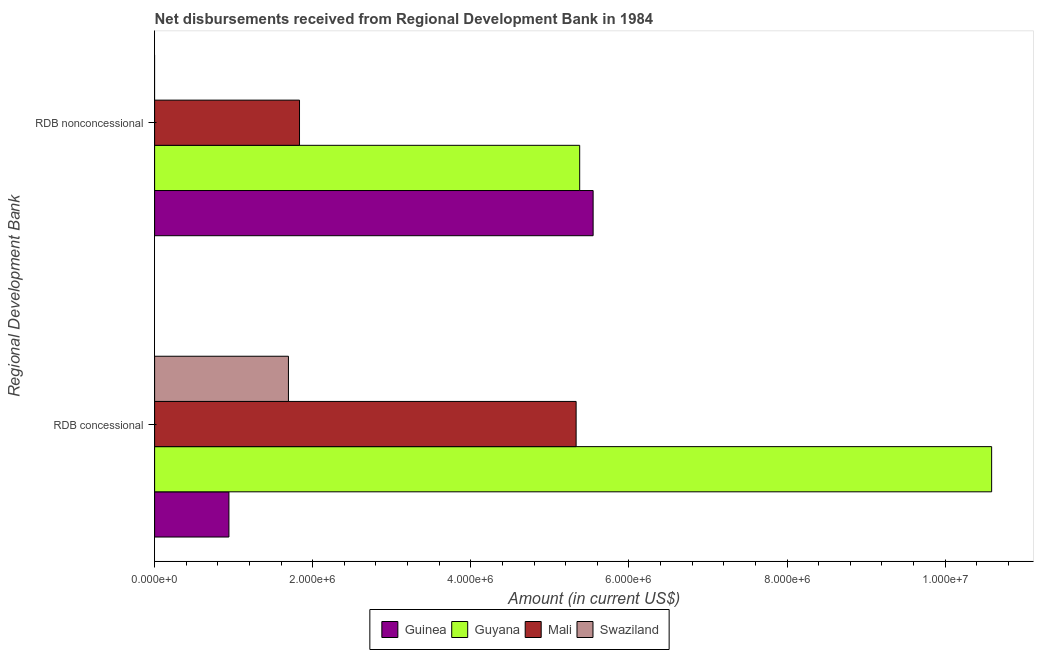How many groups of bars are there?
Make the answer very short. 2. Are the number of bars per tick equal to the number of legend labels?
Your response must be concise. No. How many bars are there on the 1st tick from the bottom?
Give a very brief answer. 4. What is the label of the 2nd group of bars from the top?
Your answer should be very brief. RDB concessional. What is the net non concessional disbursements from rdb in Mali?
Provide a succinct answer. 1.83e+06. Across all countries, what is the maximum net concessional disbursements from rdb?
Give a very brief answer. 1.06e+07. In which country was the net concessional disbursements from rdb maximum?
Provide a succinct answer. Guyana. What is the total net concessional disbursements from rdb in the graph?
Keep it short and to the point. 1.86e+07. What is the difference between the net non concessional disbursements from rdb in Guyana and that in Mali?
Provide a short and direct response. 3.54e+06. What is the difference between the net concessional disbursements from rdb in Mali and the net non concessional disbursements from rdb in Guinea?
Offer a terse response. -2.15e+05. What is the average net non concessional disbursements from rdb per country?
Ensure brevity in your answer.  3.19e+06. What is the difference between the net concessional disbursements from rdb and net non concessional disbursements from rdb in Guyana?
Offer a terse response. 5.21e+06. What is the ratio of the net concessional disbursements from rdb in Guyana to that in Mali?
Provide a succinct answer. 1.99. Is the net concessional disbursements from rdb in Mali less than that in Guyana?
Offer a very short reply. Yes. How many bars are there?
Ensure brevity in your answer.  7. How many countries are there in the graph?
Give a very brief answer. 4. Does the graph contain grids?
Your answer should be compact. No. How many legend labels are there?
Make the answer very short. 4. How are the legend labels stacked?
Your response must be concise. Horizontal. What is the title of the graph?
Provide a short and direct response. Net disbursements received from Regional Development Bank in 1984. Does "Nigeria" appear as one of the legend labels in the graph?
Your answer should be compact. No. What is the label or title of the Y-axis?
Offer a very short reply. Regional Development Bank. What is the Amount (in current US$) of Guinea in RDB concessional?
Give a very brief answer. 9.40e+05. What is the Amount (in current US$) of Guyana in RDB concessional?
Make the answer very short. 1.06e+07. What is the Amount (in current US$) of Mali in RDB concessional?
Offer a terse response. 5.33e+06. What is the Amount (in current US$) of Swaziland in RDB concessional?
Offer a terse response. 1.69e+06. What is the Amount (in current US$) of Guinea in RDB nonconcessional?
Offer a very short reply. 5.55e+06. What is the Amount (in current US$) in Guyana in RDB nonconcessional?
Your response must be concise. 5.38e+06. What is the Amount (in current US$) of Mali in RDB nonconcessional?
Your response must be concise. 1.83e+06. What is the Amount (in current US$) in Swaziland in RDB nonconcessional?
Give a very brief answer. 0. Across all Regional Development Bank, what is the maximum Amount (in current US$) of Guinea?
Provide a short and direct response. 5.55e+06. Across all Regional Development Bank, what is the maximum Amount (in current US$) in Guyana?
Provide a short and direct response. 1.06e+07. Across all Regional Development Bank, what is the maximum Amount (in current US$) in Mali?
Offer a terse response. 5.33e+06. Across all Regional Development Bank, what is the maximum Amount (in current US$) of Swaziland?
Provide a succinct answer. 1.69e+06. Across all Regional Development Bank, what is the minimum Amount (in current US$) in Guinea?
Ensure brevity in your answer.  9.40e+05. Across all Regional Development Bank, what is the minimum Amount (in current US$) of Guyana?
Provide a succinct answer. 5.38e+06. Across all Regional Development Bank, what is the minimum Amount (in current US$) of Mali?
Your answer should be very brief. 1.83e+06. Across all Regional Development Bank, what is the minimum Amount (in current US$) of Swaziland?
Provide a succinct answer. 0. What is the total Amount (in current US$) in Guinea in the graph?
Provide a succinct answer. 6.49e+06. What is the total Amount (in current US$) of Guyana in the graph?
Ensure brevity in your answer.  1.60e+07. What is the total Amount (in current US$) in Mali in the graph?
Offer a terse response. 7.16e+06. What is the total Amount (in current US$) in Swaziland in the graph?
Your answer should be compact. 1.69e+06. What is the difference between the Amount (in current US$) of Guinea in RDB concessional and that in RDB nonconcessional?
Make the answer very short. -4.61e+06. What is the difference between the Amount (in current US$) in Guyana in RDB concessional and that in RDB nonconcessional?
Provide a succinct answer. 5.21e+06. What is the difference between the Amount (in current US$) in Mali in RDB concessional and that in RDB nonconcessional?
Ensure brevity in your answer.  3.50e+06. What is the difference between the Amount (in current US$) in Guinea in RDB concessional and the Amount (in current US$) in Guyana in RDB nonconcessional?
Your response must be concise. -4.44e+06. What is the difference between the Amount (in current US$) of Guinea in RDB concessional and the Amount (in current US$) of Mali in RDB nonconcessional?
Keep it short and to the point. -8.93e+05. What is the difference between the Amount (in current US$) in Guyana in RDB concessional and the Amount (in current US$) in Mali in RDB nonconcessional?
Provide a succinct answer. 8.76e+06. What is the average Amount (in current US$) of Guinea per Regional Development Bank?
Provide a short and direct response. 3.24e+06. What is the average Amount (in current US$) of Guyana per Regional Development Bank?
Your answer should be very brief. 7.98e+06. What is the average Amount (in current US$) of Mali per Regional Development Bank?
Provide a short and direct response. 3.58e+06. What is the average Amount (in current US$) in Swaziland per Regional Development Bank?
Your response must be concise. 8.46e+05. What is the difference between the Amount (in current US$) of Guinea and Amount (in current US$) of Guyana in RDB concessional?
Your answer should be very brief. -9.65e+06. What is the difference between the Amount (in current US$) of Guinea and Amount (in current US$) of Mali in RDB concessional?
Offer a terse response. -4.39e+06. What is the difference between the Amount (in current US$) in Guinea and Amount (in current US$) in Swaziland in RDB concessional?
Your answer should be compact. -7.53e+05. What is the difference between the Amount (in current US$) in Guyana and Amount (in current US$) in Mali in RDB concessional?
Your answer should be compact. 5.26e+06. What is the difference between the Amount (in current US$) of Guyana and Amount (in current US$) of Swaziland in RDB concessional?
Make the answer very short. 8.90e+06. What is the difference between the Amount (in current US$) of Mali and Amount (in current US$) of Swaziland in RDB concessional?
Give a very brief answer. 3.64e+06. What is the difference between the Amount (in current US$) of Guinea and Amount (in current US$) of Guyana in RDB nonconcessional?
Ensure brevity in your answer.  1.70e+05. What is the difference between the Amount (in current US$) in Guinea and Amount (in current US$) in Mali in RDB nonconcessional?
Give a very brief answer. 3.71e+06. What is the difference between the Amount (in current US$) in Guyana and Amount (in current US$) in Mali in RDB nonconcessional?
Your answer should be very brief. 3.54e+06. What is the ratio of the Amount (in current US$) of Guinea in RDB concessional to that in RDB nonconcessional?
Your response must be concise. 0.17. What is the ratio of the Amount (in current US$) of Guyana in RDB concessional to that in RDB nonconcessional?
Provide a succinct answer. 1.97. What is the ratio of the Amount (in current US$) of Mali in RDB concessional to that in RDB nonconcessional?
Provide a succinct answer. 2.91. What is the difference between the highest and the second highest Amount (in current US$) of Guinea?
Your answer should be very brief. 4.61e+06. What is the difference between the highest and the second highest Amount (in current US$) of Guyana?
Provide a succinct answer. 5.21e+06. What is the difference between the highest and the second highest Amount (in current US$) in Mali?
Your answer should be very brief. 3.50e+06. What is the difference between the highest and the lowest Amount (in current US$) in Guinea?
Ensure brevity in your answer.  4.61e+06. What is the difference between the highest and the lowest Amount (in current US$) in Guyana?
Provide a short and direct response. 5.21e+06. What is the difference between the highest and the lowest Amount (in current US$) of Mali?
Provide a succinct answer. 3.50e+06. What is the difference between the highest and the lowest Amount (in current US$) in Swaziland?
Offer a very short reply. 1.69e+06. 